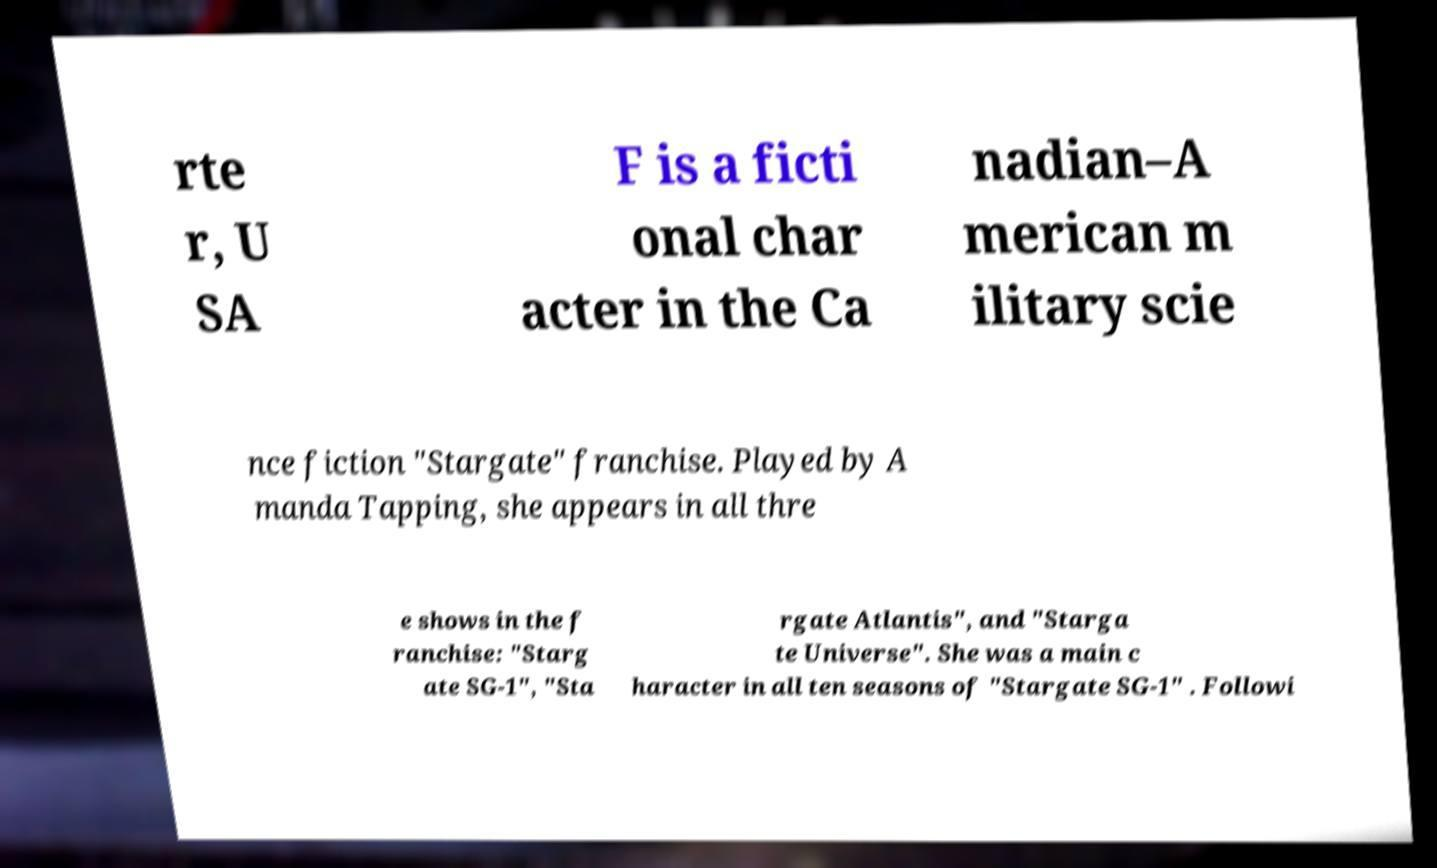Can you read and provide the text displayed in the image?This photo seems to have some interesting text. Can you extract and type it out for me? rte r, U SA F is a ficti onal char acter in the Ca nadian–A merican m ilitary scie nce fiction "Stargate" franchise. Played by A manda Tapping, she appears in all thre e shows in the f ranchise: "Starg ate SG-1", "Sta rgate Atlantis", and "Starga te Universe". She was a main c haracter in all ten seasons of "Stargate SG-1" . Followi 